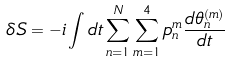<formula> <loc_0><loc_0><loc_500><loc_500>\delta S = - i \int d t \sum _ { n = 1 } ^ { N } \sum _ { m = 1 } ^ { 4 } p _ { n } ^ { m } \frac { d \theta _ { n } ^ { ( m ) } } { d t }</formula> 